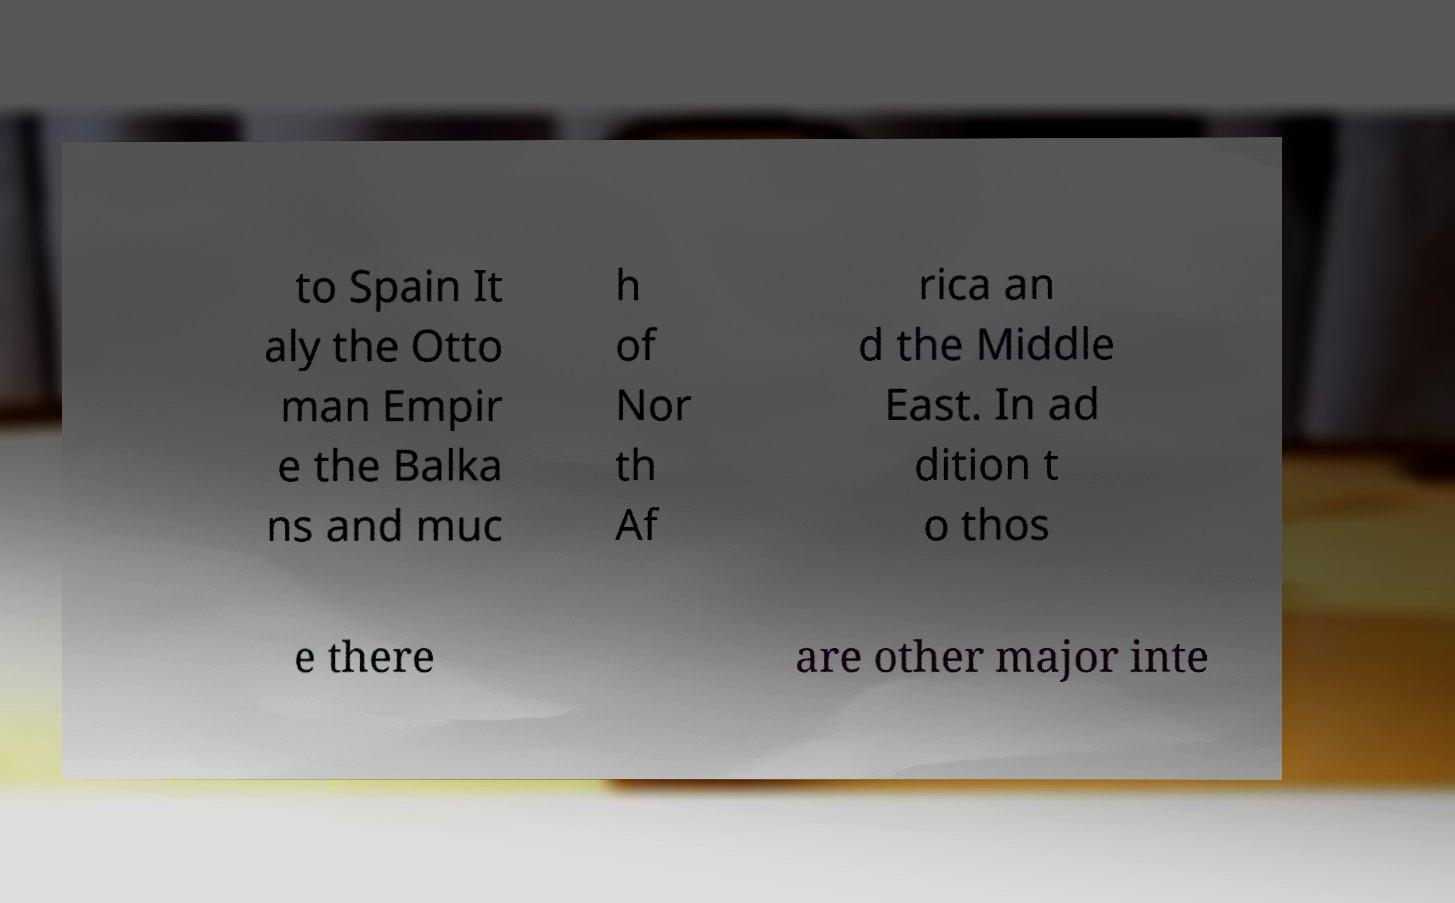Can you read and provide the text displayed in the image?This photo seems to have some interesting text. Can you extract and type it out for me? to Spain It aly the Otto man Empir e the Balka ns and muc h of Nor th Af rica an d the Middle East. In ad dition t o thos e there are other major inte 